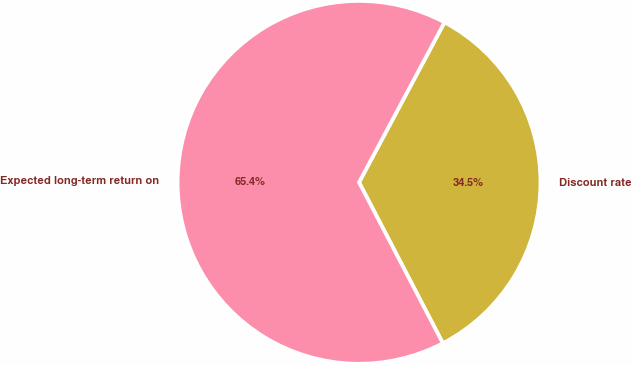Convert chart to OTSL. <chart><loc_0><loc_0><loc_500><loc_500><pie_chart><fcel>Discount rate<fcel>Expected long-term return on<nl><fcel>34.55%<fcel>65.45%<nl></chart> 